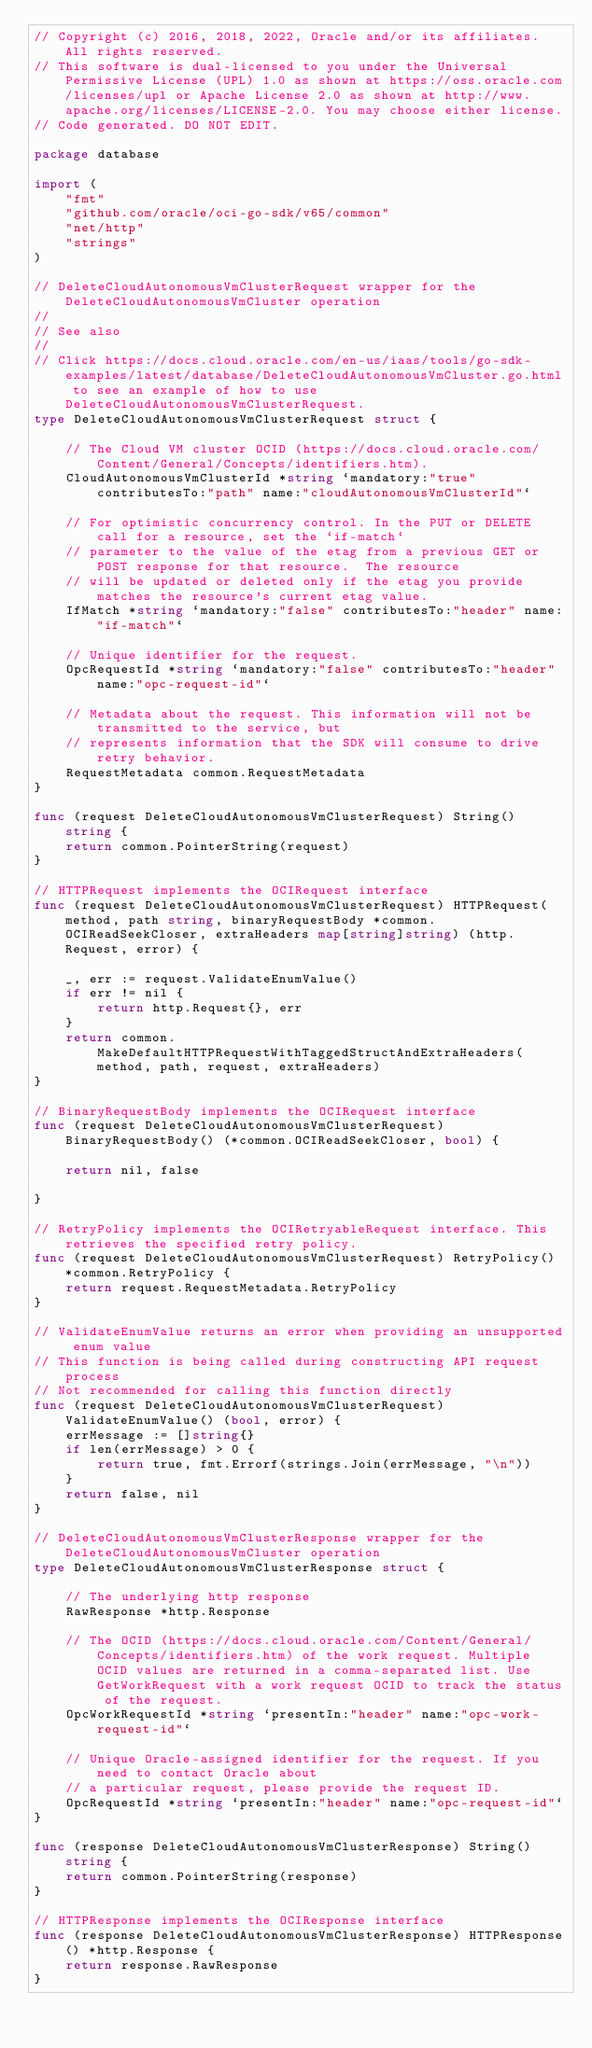<code> <loc_0><loc_0><loc_500><loc_500><_Go_>// Copyright (c) 2016, 2018, 2022, Oracle and/or its affiliates.  All rights reserved.
// This software is dual-licensed to you under the Universal Permissive License (UPL) 1.0 as shown at https://oss.oracle.com/licenses/upl or Apache License 2.0 as shown at http://www.apache.org/licenses/LICENSE-2.0. You may choose either license.
// Code generated. DO NOT EDIT.

package database

import (
	"fmt"
	"github.com/oracle/oci-go-sdk/v65/common"
	"net/http"
	"strings"
)

// DeleteCloudAutonomousVmClusterRequest wrapper for the DeleteCloudAutonomousVmCluster operation
//
// See also
//
// Click https://docs.cloud.oracle.com/en-us/iaas/tools/go-sdk-examples/latest/database/DeleteCloudAutonomousVmCluster.go.html to see an example of how to use DeleteCloudAutonomousVmClusterRequest.
type DeleteCloudAutonomousVmClusterRequest struct {

	// The Cloud VM cluster OCID (https://docs.cloud.oracle.com/Content/General/Concepts/identifiers.htm).
	CloudAutonomousVmClusterId *string `mandatory:"true" contributesTo:"path" name:"cloudAutonomousVmClusterId"`

	// For optimistic concurrency control. In the PUT or DELETE call for a resource, set the `if-match`
	// parameter to the value of the etag from a previous GET or POST response for that resource.  The resource
	// will be updated or deleted only if the etag you provide matches the resource's current etag value.
	IfMatch *string `mandatory:"false" contributesTo:"header" name:"if-match"`

	// Unique identifier for the request.
	OpcRequestId *string `mandatory:"false" contributesTo:"header" name:"opc-request-id"`

	// Metadata about the request. This information will not be transmitted to the service, but
	// represents information that the SDK will consume to drive retry behavior.
	RequestMetadata common.RequestMetadata
}

func (request DeleteCloudAutonomousVmClusterRequest) String() string {
	return common.PointerString(request)
}

// HTTPRequest implements the OCIRequest interface
func (request DeleteCloudAutonomousVmClusterRequest) HTTPRequest(method, path string, binaryRequestBody *common.OCIReadSeekCloser, extraHeaders map[string]string) (http.Request, error) {

	_, err := request.ValidateEnumValue()
	if err != nil {
		return http.Request{}, err
	}
	return common.MakeDefaultHTTPRequestWithTaggedStructAndExtraHeaders(method, path, request, extraHeaders)
}

// BinaryRequestBody implements the OCIRequest interface
func (request DeleteCloudAutonomousVmClusterRequest) BinaryRequestBody() (*common.OCIReadSeekCloser, bool) {

	return nil, false

}

// RetryPolicy implements the OCIRetryableRequest interface. This retrieves the specified retry policy.
func (request DeleteCloudAutonomousVmClusterRequest) RetryPolicy() *common.RetryPolicy {
	return request.RequestMetadata.RetryPolicy
}

// ValidateEnumValue returns an error when providing an unsupported enum value
// This function is being called during constructing API request process
// Not recommended for calling this function directly
func (request DeleteCloudAutonomousVmClusterRequest) ValidateEnumValue() (bool, error) {
	errMessage := []string{}
	if len(errMessage) > 0 {
		return true, fmt.Errorf(strings.Join(errMessage, "\n"))
	}
	return false, nil
}

// DeleteCloudAutonomousVmClusterResponse wrapper for the DeleteCloudAutonomousVmCluster operation
type DeleteCloudAutonomousVmClusterResponse struct {

	// The underlying http response
	RawResponse *http.Response

	// The OCID (https://docs.cloud.oracle.com/Content/General/Concepts/identifiers.htm) of the work request. Multiple OCID values are returned in a comma-separated list. Use GetWorkRequest with a work request OCID to track the status of the request.
	OpcWorkRequestId *string `presentIn:"header" name:"opc-work-request-id"`

	// Unique Oracle-assigned identifier for the request. If you need to contact Oracle about
	// a particular request, please provide the request ID.
	OpcRequestId *string `presentIn:"header" name:"opc-request-id"`
}

func (response DeleteCloudAutonomousVmClusterResponse) String() string {
	return common.PointerString(response)
}

// HTTPResponse implements the OCIResponse interface
func (response DeleteCloudAutonomousVmClusterResponse) HTTPResponse() *http.Response {
	return response.RawResponse
}
</code> 